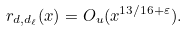<formula> <loc_0><loc_0><loc_500><loc_500>r _ { d , d _ { \ell } } ( x ) = O _ { u } ( x ^ { 1 3 / 1 6 + \varepsilon } ) .</formula> 